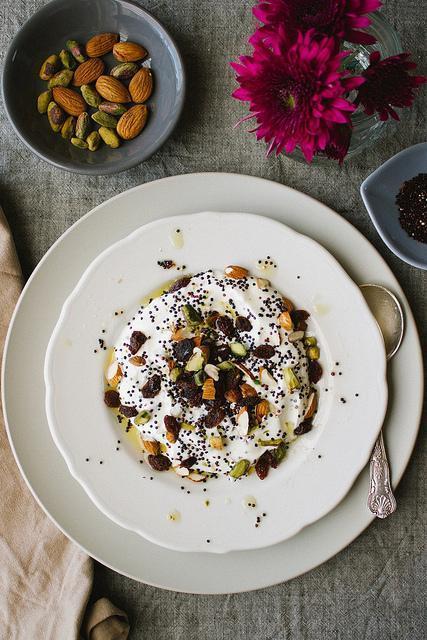How many bowls are there?
Give a very brief answer. 2. 